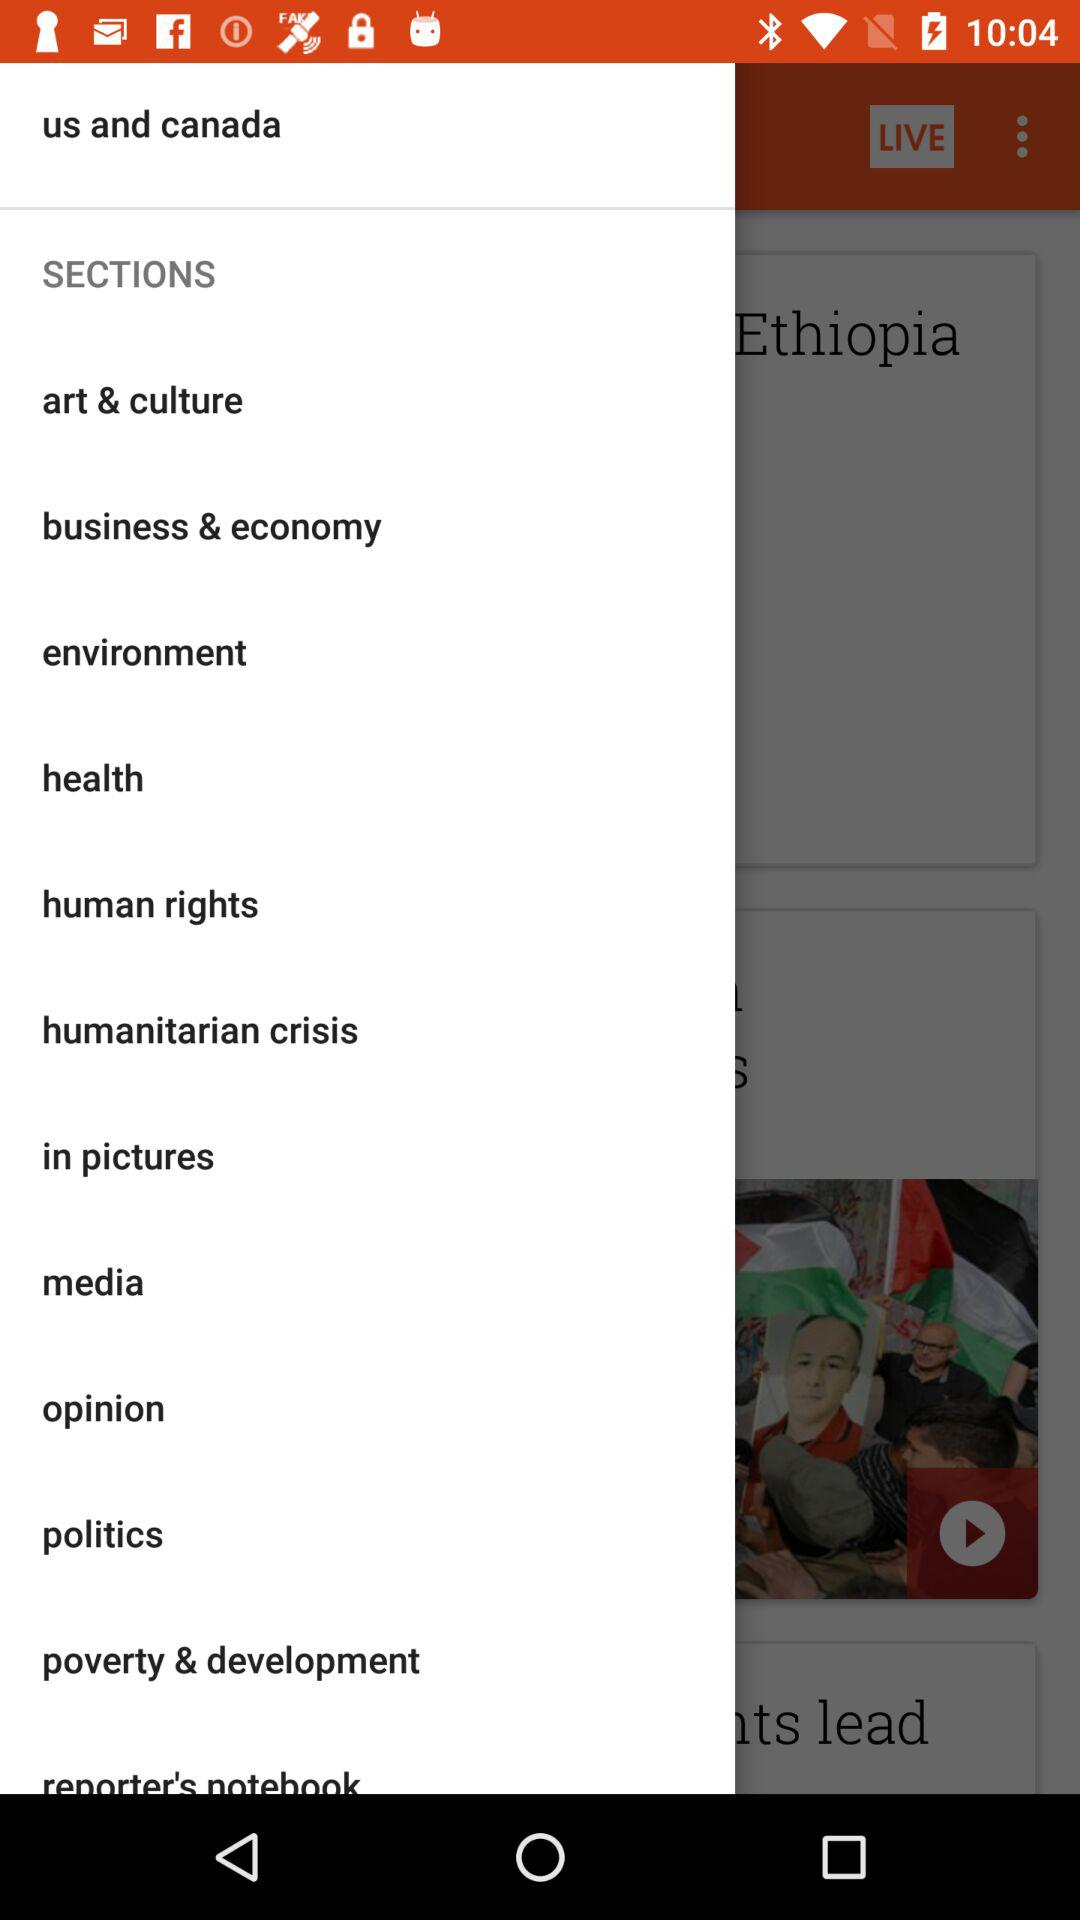How many sections are there in total?
Answer the question using a single word or phrase. 12 